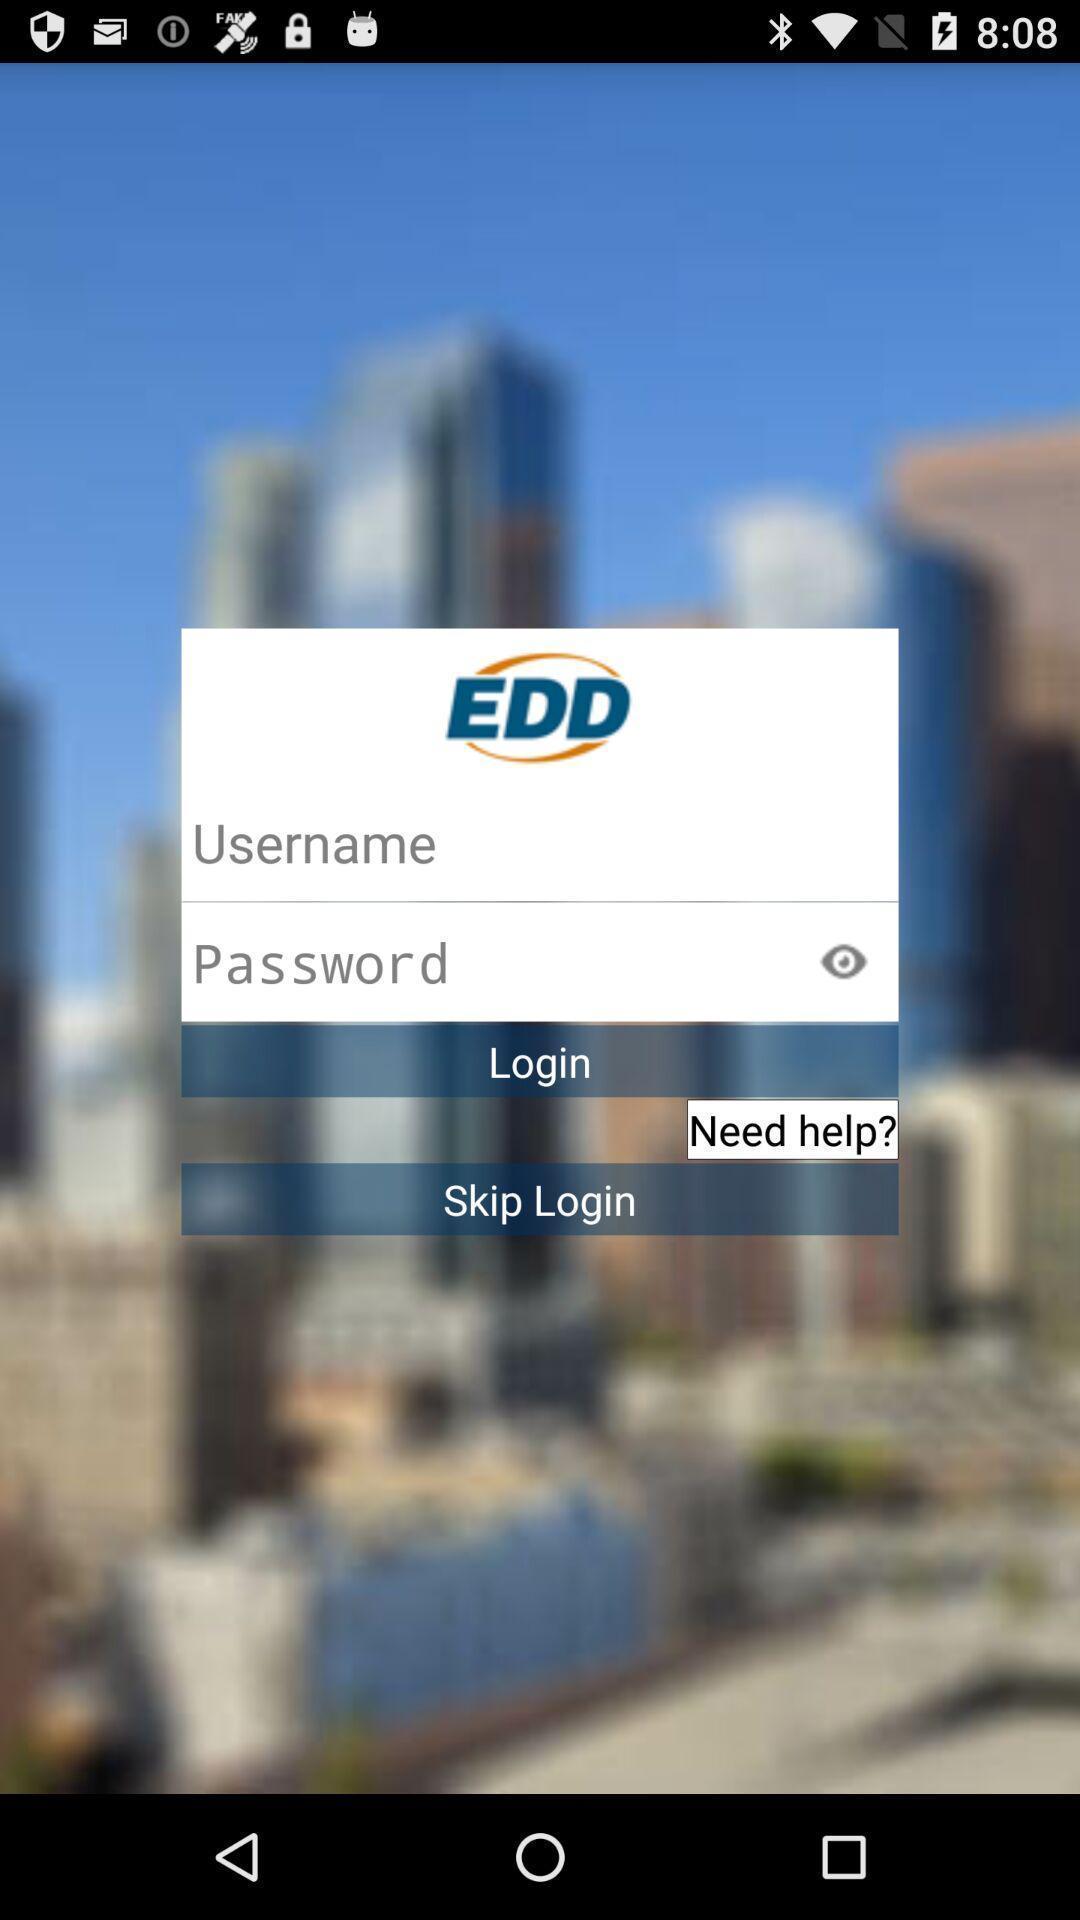Describe this image in words. Welcome page for an app. 